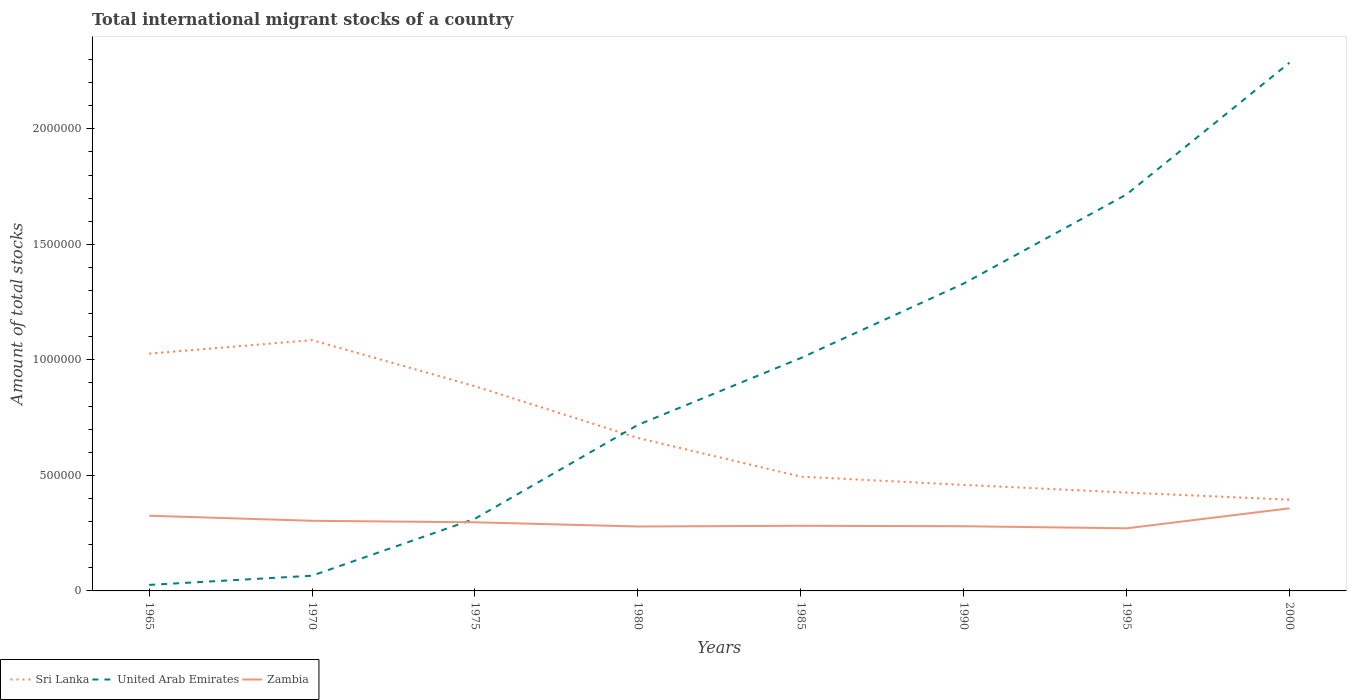How many different coloured lines are there?
Provide a succinct answer. 3. Does the line corresponding to Zambia intersect with the line corresponding to Sri Lanka?
Your response must be concise. No. Is the number of lines equal to the number of legend labels?
Provide a succinct answer. Yes. Across all years, what is the maximum amount of total stocks in in Zambia?
Give a very brief answer. 2.71e+05. In which year was the amount of total stocks in in Sri Lanka maximum?
Your answer should be compact. 2000. What is the total amount of total stocks in in Zambia in the graph?
Make the answer very short. 3.25e+04. What is the difference between the highest and the second highest amount of total stocks in in United Arab Emirates?
Offer a terse response. 2.26e+06. What is the difference between two consecutive major ticks on the Y-axis?
Keep it short and to the point. 5.00e+05. How many legend labels are there?
Your answer should be very brief. 3. What is the title of the graph?
Your answer should be very brief. Total international migrant stocks of a country. What is the label or title of the Y-axis?
Offer a terse response. Amount of total stocks. What is the Amount of total stocks in Sri Lanka in 1965?
Keep it short and to the point. 1.03e+06. What is the Amount of total stocks of United Arab Emirates in 1965?
Keep it short and to the point. 2.60e+04. What is the Amount of total stocks of Zambia in 1965?
Offer a terse response. 3.26e+05. What is the Amount of total stocks in Sri Lanka in 1970?
Your answer should be compact. 1.09e+06. What is the Amount of total stocks of United Arab Emirates in 1970?
Your answer should be compact. 6.58e+04. What is the Amount of total stocks of Zambia in 1970?
Your answer should be very brief. 3.03e+05. What is the Amount of total stocks in Sri Lanka in 1975?
Offer a very short reply. 8.86e+05. What is the Amount of total stocks of United Arab Emirates in 1975?
Ensure brevity in your answer.  3.12e+05. What is the Amount of total stocks of Zambia in 1975?
Provide a short and direct response. 2.97e+05. What is the Amount of total stocks in Sri Lanka in 1980?
Offer a terse response. 6.62e+05. What is the Amount of total stocks in United Arab Emirates in 1980?
Provide a short and direct response. 7.18e+05. What is the Amount of total stocks of Zambia in 1980?
Keep it short and to the point. 2.79e+05. What is the Amount of total stocks of Sri Lanka in 1985?
Your answer should be very brief. 4.95e+05. What is the Amount of total stocks of United Arab Emirates in 1985?
Your answer should be compact. 1.01e+06. What is the Amount of total stocks of Zambia in 1985?
Keep it short and to the point. 2.82e+05. What is the Amount of total stocks in Sri Lanka in 1990?
Keep it short and to the point. 4.59e+05. What is the Amount of total stocks of United Arab Emirates in 1990?
Give a very brief answer. 1.33e+06. What is the Amount of total stocks in Zambia in 1990?
Keep it short and to the point. 2.80e+05. What is the Amount of total stocks in Sri Lanka in 1995?
Offer a very short reply. 4.26e+05. What is the Amount of total stocks in United Arab Emirates in 1995?
Offer a terse response. 1.72e+06. What is the Amount of total stocks of Zambia in 1995?
Provide a short and direct response. 2.71e+05. What is the Amount of total stocks of Sri Lanka in 2000?
Keep it short and to the point. 3.95e+05. What is the Amount of total stocks of United Arab Emirates in 2000?
Your answer should be compact. 2.29e+06. What is the Amount of total stocks of Zambia in 2000?
Make the answer very short. 3.57e+05. Across all years, what is the maximum Amount of total stocks of Sri Lanka?
Your answer should be compact. 1.09e+06. Across all years, what is the maximum Amount of total stocks of United Arab Emirates?
Offer a terse response. 2.29e+06. Across all years, what is the maximum Amount of total stocks in Zambia?
Ensure brevity in your answer.  3.57e+05. Across all years, what is the minimum Amount of total stocks in Sri Lanka?
Your answer should be compact. 3.95e+05. Across all years, what is the minimum Amount of total stocks of United Arab Emirates?
Your answer should be very brief. 2.60e+04. Across all years, what is the minimum Amount of total stocks in Zambia?
Your answer should be very brief. 2.71e+05. What is the total Amount of total stocks of Sri Lanka in the graph?
Provide a short and direct response. 5.43e+06. What is the total Amount of total stocks of United Arab Emirates in the graph?
Provide a succinct answer. 7.46e+06. What is the total Amount of total stocks of Zambia in the graph?
Your response must be concise. 2.40e+06. What is the difference between the Amount of total stocks in Sri Lanka in 1965 and that in 1970?
Your answer should be very brief. -5.85e+04. What is the difference between the Amount of total stocks in United Arab Emirates in 1965 and that in 1970?
Provide a succinct answer. -3.98e+04. What is the difference between the Amount of total stocks of Zambia in 1965 and that in 1970?
Offer a very short reply. 2.20e+04. What is the difference between the Amount of total stocks of Sri Lanka in 1965 and that in 1975?
Offer a very short reply. 1.41e+05. What is the difference between the Amount of total stocks in United Arab Emirates in 1965 and that in 1975?
Keep it short and to the point. -2.86e+05. What is the difference between the Amount of total stocks in Zambia in 1965 and that in 1975?
Offer a very short reply. 2.84e+04. What is the difference between the Amount of total stocks in Sri Lanka in 1965 and that in 1980?
Provide a short and direct response. 3.65e+05. What is the difference between the Amount of total stocks in United Arab Emirates in 1965 and that in 1980?
Your answer should be very brief. -6.92e+05. What is the difference between the Amount of total stocks of Zambia in 1965 and that in 1980?
Offer a very short reply. 4.67e+04. What is the difference between the Amount of total stocks in Sri Lanka in 1965 and that in 1985?
Provide a succinct answer. 5.32e+05. What is the difference between the Amount of total stocks in United Arab Emirates in 1965 and that in 1985?
Provide a succinct answer. -9.82e+05. What is the difference between the Amount of total stocks in Zambia in 1965 and that in 1985?
Offer a very short reply. 4.36e+04. What is the difference between the Amount of total stocks in Sri Lanka in 1965 and that in 1990?
Provide a short and direct response. 5.68e+05. What is the difference between the Amount of total stocks in United Arab Emirates in 1965 and that in 1990?
Offer a very short reply. -1.30e+06. What is the difference between the Amount of total stocks of Zambia in 1965 and that in 1990?
Make the answer very short. 4.55e+04. What is the difference between the Amount of total stocks of Sri Lanka in 1965 and that in 1995?
Your answer should be compact. 6.01e+05. What is the difference between the Amount of total stocks of United Arab Emirates in 1965 and that in 1995?
Ensure brevity in your answer.  -1.69e+06. What is the difference between the Amount of total stocks in Zambia in 1965 and that in 1995?
Ensure brevity in your answer.  5.46e+04. What is the difference between the Amount of total stocks in Sri Lanka in 1965 and that in 2000?
Offer a very short reply. 6.32e+05. What is the difference between the Amount of total stocks of United Arab Emirates in 1965 and that in 2000?
Ensure brevity in your answer.  -2.26e+06. What is the difference between the Amount of total stocks of Zambia in 1965 and that in 2000?
Your answer should be compact. -3.20e+04. What is the difference between the Amount of total stocks in Sri Lanka in 1970 and that in 1975?
Make the answer very short. 2.00e+05. What is the difference between the Amount of total stocks in United Arab Emirates in 1970 and that in 1975?
Keep it short and to the point. -2.47e+05. What is the difference between the Amount of total stocks of Zambia in 1970 and that in 1975?
Make the answer very short. 6393. What is the difference between the Amount of total stocks in Sri Lanka in 1970 and that in 1980?
Make the answer very short. 4.24e+05. What is the difference between the Amount of total stocks in United Arab Emirates in 1970 and that in 1980?
Your response must be concise. -6.53e+05. What is the difference between the Amount of total stocks of Zambia in 1970 and that in 1980?
Offer a very short reply. 2.47e+04. What is the difference between the Amount of total stocks in Sri Lanka in 1970 and that in 1985?
Your response must be concise. 5.91e+05. What is the difference between the Amount of total stocks of United Arab Emirates in 1970 and that in 1985?
Keep it short and to the point. -9.42e+05. What is the difference between the Amount of total stocks in Zambia in 1970 and that in 1985?
Your response must be concise. 2.16e+04. What is the difference between the Amount of total stocks of Sri Lanka in 1970 and that in 1990?
Offer a terse response. 6.27e+05. What is the difference between the Amount of total stocks of United Arab Emirates in 1970 and that in 1990?
Make the answer very short. -1.26e+06. What is the difference between the Amount of total stocks in Zambia in 1970 and that in 1990?
Give a very brief answer. 2.35e+04. What is the difference between the Amount of total stocks in Sri Lanka in 1970 and that in 1995?
Your answer should be very brief. 6.60e+05. What is the difference between the Amount of total stocks of United Arab Emirates in 1970 and that in 1995?
Keep it short and to the point. -1.65e+06. What is the difference between the Amount of total stocks in Zambia in 1970 and that in 1995?
Ensure brevity in your answer.  3.25e+04. What is the difference between the Amount of total stocks in Sri Lanka in 1970 and that in 2000?
Ensure brevity in your answer.  6.90e+05. What is the difference between the Amount of total stocks in United Arab Emirates in 1970 and that in 2000?
Give a very brief answer. -2.22e+06. What is the difference between the Amount of total stocks of Zambia in 1970 and that in 2000?
Keep it short and to the point. -5.40e+04. What is the difference between the Amount of total stocks of Sri Lanka in 1975 and that in 1980?
Offer a terse response. 2.24e+05. What is the difference between the Amount of total stocks in United Arab Emirates in 1975 and that in 1980?
Provide a short and direct response. -4.06e+05. What is the difference between the Amount of total stocks in Zambia in 1975 and that in 1980?
Offer a very short reply. 1.83e+04. What is the difference between the Amount of total stocks of Sri Lanka in 1975 and that in 1985?
Provide a short and direct response. 3.91e+05. What is the difference between the Amount of total stocks of United Arab Emirates in 1975 and that in 1985?
Make the answer very short. -6.95e+05. What is the difference between the Amount of total stocks in Zambia in 1975 and that in 1985?
Keep it short and to the point. 1.52e+04. What is the difference between the Amount of total stocks of Sri Lanka in 1975 and that in 1990?
Offer a terse response. 4.27e+05. What is the difference between the Amount of total stocks in United Arab Emirates in 1975 and that in 1990?
Your answer should be very brief. -1.02e+06. What is the difference between the Amount of total stocks of Zambia in 1975 and that in 1990?
Keep it short and to the point. 1.71e+04. What is the difference between the Amount of total stocks of Sri Lanka in 1975 and that in 1995?
Your response must be concise. 4.60e+05. What is the difference between the Amount of total stocks of United Arab Emirates in 1975 and that in 1995?
Provide a short and direct response. -1.40e+06. What is the difference between the Amount of total stocks in Zambia in 1975 and that in 1995?
Offer a terse response. 2.61e+04. What is the difference between the Amount of total stocks of Sri Lanka in 1975 and that in 2000?
Ensure brevity in your answer.  4.91e+05. What is the difference between the Amount of total stocks of United Arab Emirates in 1975 and that in 2000?
Ensure brevity in your answer.  -1.97e+06. What is the difference between the Amount of total stocks of Zambia in 1975 and that in 2000?
Ensure brevity in your answer.  -6.04e+04. What is the difference between the Amount of total stocks of Sri Lanka in 1980 and that in 1985?
Ensure brevity in your answer.  1.67e+05. What is the difference between the Amount of total stocks of United Arab Emirates in 1980 and that in 1985?
Give a very brief answer. -2.89e+05. What is the difference between the Amount of total stocks of Zambia in 1980 and that in 1985?
Offer a terse response. -3108. What is the difference between the Amount of total stocks in Sri Lanka in 1980 and that in 1990?
Keep it short and to the point. 2.03e+05. What is the difference between the Amount of total stocks of United Arab Emirates in 1980 and that in 1990?
Keep it short and to the point. -6.12e+05. What is the difference between the Amount of total stocks of Zambia in 1980 and that in 1990?
Provide a succinct answer. -1171. What is the difference between the Amount of total stocks in Sri Lanka in 1980 and that in 1995?
Provide a succinct answer. 2.36e+05. What is the difference between the Amount of total stocks of United Arab Emirates in 1980 and that in 1995?
Your response must be concise. -9.98e+05. What is the difference between the Amount of total stocks in Zambia in 1980 and that in 1995?
Your answer should be very brief. 7841. What is the difference between the Amount of total stocks in Sri Lanka in 1980 and that in 2000?
Ensure brevity in your answer.  2.67e+05. What is the difference between the Amount of total stocks of United Arab Emirates in 1980 and that in 2000?
Make the answer very short. -1.57e+06. What is the difference between the Amount of total stocks of Zambia in 1980 and that in 2000?
Give a very brief answer. -7.87e+04. What is the difference between the Amount of total stocks in Sri Lanka in 1985 and that in 1990?
Provide a short and direct response. 3.57e+04. What is the difference between the Amount of total stocks in United Arab Emirates in 1985 and that in 1990?
Your answer should be very brief. -3.22e+05. What is the difference between the Amount of total stocks of Zambia in 1985 and that in 1990?
Make the answer very short. 1937. What is the difference between the Amount of total stocks in Sri Lanka in 1985 and that in 1995?
Make the answer very short. 6.89e+04. What is the difference between the Amount of total stocks of United Arab Emirates in 1985 and that in 1995?
Ensure brevity in your answer.  -7.08e+05. What is the difference between the Amount of total stocks in Zambia in 1985 and that in 1995?
Give a very brief answer. 1.09e+04. What is the difference between the Amount of total stocks in Sri Lanka in 1985 and that in 2000?
Your answer should be very brief. 9.97e+04. What is the difference between the Amount of total stocks in United Arab Emirates in 1985 and that in 2000?
Provide a succinct answer. -1.28e+06. What is the difference between the Amount of total stocks in Zambia in 1985 and that in 2000?
Keep it short and to the point. -7.56e+04. What is the difference between the Amount of total stocks in Sri Lanka in 1990 and that in 1995?
Provide a short and direct response. 3.32e+04. What is the difference between the Amount of total stocks in United Arab Emirates in 1990 and that in 1995?
Give a very brief answer. -3.86e+05. What is the difference between the Amount of total stocks in Zambia in 1990 and that in 1995?
Your answer should be compact. 9012. What is the difference between the Amount of total stocks in Sri Lanka in 1990 and that in 2000?
Your answer should be very brief. 6.39e+04. What is the difference between the Amount of total stocks in United Arab Emirates in 1990 and that in 2000?
Ensure brevity in your answer.  -9.56e+05. What is the difference between the Amount of total stocks in Zambia in 1990 and that in 2000?
Make the answer very short. -7.75e+04. What is the difference between the Amount of total stocks in Sri Lanka in 1995 and that in 2000?
Make the answer very short. 3.08e+04. What is the difference between the Amount of total stocks in United Arab Emirates in 1995 and that in 2000?
Your answer should be very brief. -5.70e+05. What is the difference between the Amount of total stocks of Zambia in 1995 and that in 2000?
Your answer should be very brief. -8.65e+04. What is the difference between the Amount of total stocks in Sri Lanka in 1965 and the Amount of total stocks in United Arab Emirates in 1970?
Provide a short and direct response. 9.61e+05. What is the difference between the Amount of total stocks of Sri Lanka in 1965 and the Amount of total stocks of Zambia in 1970?
Give a very brief answer. 7.23e+05. What is the difference between the Amount of total stocks in United Arab Emirates in 1965 and the Amount of total stocks in Zambia in 1970?
Provide a short and direct response. -2.77e+05. What is the difference between the Amount of total stocks in Sri Lanka in 1965 and the Amount of total stocks in United Arab Emirates in 1975?
Give a very brief answer. 7.14e+05. What is the difference between the Amount of total stocks of Sri Lanka in 1965 and the Amount of total stocks of Zambia in 1975?
Offer a terse response. 7.30e+05. What is the difference between the Amount of total stocks in United Arab Emirates in 1965 and the Amount of total stocks in Zambia in 1975?
Keep it short and to the point. -2.71e+05. What is the difference between the Amount of total stocks in Sri Lanka in 1965 and the Amount of total stocks in United Arab Emirates in 1980?
Your response must be concise. 3.08e+05. What is the difference between the Amount of total stocks of Sri Lanka in 1965 and the Amount of total stocks of Zambia in 1980?
Provide a succinct answer. 7.48e+05. What is the difference between the Amount of total stocks of United Arab Emirates in 1965 and the Amount of total stocks of Zambia in 1980?
Ensure brevity in your answer.  -2.53e+05. What is the difference between the Amount of total stocks of Sri Lanka in 1965 and the Amount of total stocks of United Arab Emirates in 1985?
Keep it short and to the point. 1.91e+04. What is the difference between the Amount of total stocks of Sri Lanka in 1965 and the Amount of total stocks of Zambia in 1985?
Your response must be concise. 7.45e+05. What is the difference between the Amount of total stocks in United Arab Emirates in 1965 and the Amount of total stocks in Zambia in 1985?
Ensure brevity in your answer.  -2.56e+05. What is the difference between the Amount of total stocks in Sri Lanka in 1965 and the Amount of total stocks in United Arab Emirates in 1990?
Your response must be concise. -3.03e+05. What is the difference between the Amount of total stocks in Sri Lanka in 1965 and the Amount of total stocks in Zambia in 1990?
Keep it short and to the point. 7.47e+05. What is the difference between the Amount of total stocks in United Arab Emirates in 1965 and the Amount of total stocks in Zambia in 1990?
Offer a terse response. -2.54e+05. What is the difference between the Amount of total stocks of Sri Lanka in 1965 and the Amount of total stocks of United Arab Emirates in 1995?
Provide a short and direct response. -6.89e+05. What is the difference between the Amount of total stocks of Sri Lanka in 1965 and the Amount of total stocks of Zambia in 1995?
Give a very brief answer. 7.56e+05. What is the difference between the Amount of total stocks in United Arab Emirates in 1965 and the Amount of total stocks in Zambia in 1995?
Offer a terse response. -2.45e+05. What is the difference between the Amount of total stocks in Sri Lanka in 1965 and the Amount of total stocks in United Arab Emirates in 2000?
Keep it short and to the point. -1.26e+06. What is the difference between the Amount of total stocks of Sri Lanka in 1965 and the Amount of total stocks of Zambia in 2000?
Make the answer very short. 6.69e+05. What is the difference between the Amount of total stocks of United Arab Emirates in 1965 and the Amount of total stocks of Zambia in 2000?
Provide a short and direct response. -3.31e+05. What is the difference between the Amount of total stocks in Sri Lanka in 1970 and the Amount of total stocks in United Arab Emirates in 1975?
Offer a very short reply. 7.73e+05. What is the difference between the Amount of total stocks of Sri Lanka in 1970 and the Amount of total stocks of Zambia in 1975?
Offer a very short reply. 7.88e+05. What is the difference between the Amount of total stocks in United Arab Emirates in 1970 and the Amount of total stocks in Zambia in 1975?
Offer a terse response. -2.31e+05. What is the difference between the Amount of total stocks in Sri Lanka in 1970 and the Amount of total stocks in United Arab Emirates in 1980?
Offer a terse response. 3.67e+05. What is the difference between the Amount of total stocks of Sri Lanka in 1970 and the Amount of total stocks of Zambia in 1980?
Offer a terse response. 8.07e+05. What is the difference between the Amount of total stocks in United Arab Emirates in 1970 and the Amount of total stocks in Zambia in 1980?
Your answer should be very brief. -2.13e+05. What is the difference between the Amount of total stocks of Sri Lanka in 1970 and the Amount of total stocks of United Arab Emirates in 1985?
Keep it short and to the point. 7.76e+04. What is the difference between the Amount of total stocks in Sri Lanka in 1970 and the Amount of total stocks in Zambia in 1985?
Your answer should be very brief. 8.04e+05. What is the difference between the Amount of total stocks in United Arab Emirates in 1970 and the Amount of total stocks in Zambia in 1985?
Your answer should be very brief. -2.16e+05. What is the difference between the Amount of total stocks in Sri Lanka in 1970 and the Amount of total stocks in United Arab Emirates in 1990?
Offer a very short reply. -2.45e+05. What is the difference between the Amount of total stocks in Sri Lanka in 1970 and the Amount of total stocks in Zambia in 1990?
Give a very brief answer. 8.05e+05. What is the difference between the Amount of total stocks in United Arab Emirates in 1970 and the Amount of total stocks in Zambia in 1990?
Keep it short and to the point. -2.14e+05. What is the difference between the Amount of total stocks of Sri Lanka in 1970 and the Amount of total stocks of United Arab Emirates in 1995?
Make the answer very short. -6.31e+05. What is the difference between the Amount of total stocks in Sri Lanka in 1970 and the Amount of total stocks in Zambia in 1995?
Provide a succinct answer. 8.14e+05. What is the difference between the Amount of total stocks in United Arab Emirates in 1970 and the Amount of total stocks in Zambia in 1995?
Offer a very short reply. -2.05e+05. What is the difference between the Amount of total stocks of Sri Lanka in 1970 and the Amount of total stocks of United Arab Emirates in 2000?
Ensure brevity in your answer.  -1.20e+06. What is the difference between the Amount of total stocks of Sri Lanka in 1970 and the Amount of total stocks of Zambia in 2000?
Provide a succinct answer. 7.28e+05. What is the difference between the Amount of total stocks in United Arab Emirates in 1970 and the Amount of total stocks in Zambia in 2000?
Your answer should be very brief. -2.92e+05. What is the difference between the Amount of total stocks in Sri Lanka in 1975 and the Amount of total stocks in United Arab Emirates in 1980?
Make the answer very short. 1.67e+05. What is the difference between the Amount of total stocks in Sri Lanka in 1975 and the Amount of total stocks in Zambia in 1980?
Offer a terse response. 6.07e+05. What is the difference between the Amount of total stocks in United Arab Emirates in 1975 and the Amount of total stocks in Zambia in 1980?
Your response must be concise. 3.36e+04. What is the difference between the Amount of total stocks in Sri Lanka in 1975 and the Amount of total stocks in United Arab Emirates in 1985?
Provide a succinct answer. -1.22e+05. What is the difference between the Amount of total stocks in Sri Lanka in 1975 and the Amount of total stocks in Zambia in 1985?
Ensure brevity in your answer.  6.04e+05. What is the difference between the Amount of total stocks of United Arab Emirates in 1975 and the Amount of total stocks of Zambia in 1985?
Give a very brief answer. 3.05e+04. What is the difference between the Amount of total stocks in Sri Lanka in 1975 and the Amount of total stocks in United Arab Emirates in 1990?
Your answer should be very brief. -4.44e+05. What is the difference between the Amount of total stocks in Sri Lanka in 1975 and the Amount of total stocks in Zambia in 1990?
Ensure brevity in your answer.  6.06e+05. What is the difference between the Amount of total stocks of United Arab Emirates in 1975 and the Amount of total stocks of Zambia in 1990?
Give a very brief answer. 3.24e+04. What is the difference between the Amount of total stocks of Sri Lanka in 1975 and the Amount of total stocks of United Arab Emirates in 1995?
Your answer should be compact. -8.30e+05. What is the difference between the Amount of total stocks of Sri Lanka in 1975 and the Amount of total stocks of Zambia in 1995?
Ensure brevity in your answer.  6.15e+05. What is the difference between the Amount of total stocks in United Arab Emirates in 1975 and the Amount of total stocks in Zambia in 1995?
Offer a very short reply. 4.14e+04. What is the difference between the Amount of total stocks of Sri Lanka in 1975 and the Amount of total stocks of United Arab Emirates in 2000?
Offer a terse response. -1.40e+06. What is the difference between the Amount of total stocks of Sri Lanka in 1975 and the Amount of total stocks of Zambia in 2000?
Your response must be concise. 5.28e+05. What is the difference between the Amount of total stocks of United Arab Emirates in 1975 and the Amount of total stocks of Zambia in 2000?
Provide a short and direct response. -4.51e+04. What is the difference between the Amount of total stocks in Sri Lanka in 1980 and the Amount of total stocks in United Arab Emirates in 1985?
Ensure brevity in your answer.  -3.46e+05. What is the difference between the Amount of total stocks in Sri Lanka in 1980 and the Amount of total stocks in Zambia in 1985?
Ensure brevity in your answer.  3.80e+05. What is the difference between the Amount of total stocks in United Arab Emirates in 1980 and the Amount of total stocks in Zambia in 1985?
Offer a terse response. 4.37e+05. What is the difference between the Amount of total stocks of Sri Lanka in 1980 and the Amount of total stocks of United Arab Emirates in 1990?
Your response must be concise. -6.68e+05. What is the difference between the Amount of total stocks of Sri Lanka in 1980 and the Amount of total stocks of Zambia in 1990?
Offer a very short reply. 3.82e+05. What is the difference between the Amount of total stocks of United Arab Emirates in 1980 and the Amount of total stocks of Zambia in 1990?
Offer a very short reply. 4.39e+05. What is the difference between the Amount of total stocks in Sri Lanka in 1980 and the Amount of total stocks in United Arab Emirates in 1995?
Provide a succinct answer. -1.05e+06. What is the difference between the Amount of total stocks in Sri Lanka in 1980 and the Amount of total stocks in Zambia in 1995?
Ensure brevity in your answer.  3.91e+05. What is the difference between the Amount of total stocks in United Arab Emirates in 1980 and the Amount of total stocks in Zambia in 1995?
Provide a succinct answer. 4.48e+05. What is the difference between the Amount of total stocks in Sri Lanka in 1980 and the Amount of total stocks in United Arab Emirates in 2000?
Offer a very short reply. -1.62e+06. What is the difference between the Amount of total stocks in Sri Lanka in 1980 and the Amount of total stocks in Zambia in 2000?
Provide a short and direct response. 3.04e+05. What is the difference between the Amount of total stocks of United Arab Emirates in 1980 and the Amount of total stocks of Zambia in 2000?
Offer a terse response. 3.61e+05. What is the difference between the Amount of total stocks of Sri Lanka in 1985 and the Amount of total stocks of United Arab Emirates in 1990?
Your answer should be very brief. -8.36e+05. What is the difference between the Amount of total stocks in Sri Lanka in 1985 and the Amount of total stocks in Zambia in 1990?
Offer a very short reply. 2.15e+05. What is the difference between the Amount of total stocks of United Arab Emirates in 1985 and the Amount of total stocks of Zambia in 1990?
Keep it short and to the point. 7.28e+05. What is the difference between the Amount of total stocks in Sri Lanka in 1985 and the Amount of total stocks in United Arab Emirates in 1995?
Provide a succinct answer. -1.22e+06. What is the difference between the Amount of total stocks of Sri Lanka in 1985 and the Amount of total stocks of Zambia in 1995?
Your response must be concise. 2.24e+05. What is the difference between the Amount of total stocks of United Arab Emirates in 1985 and the Amount of total stocks of Zambia in 1995?
Provide a short and direct response. 7.37e+05. What is the difference between the Amount of total stocks of Sri Lanka in 1985 and the Amount of total stocks of United Arab Emirates in 2000?
Keep it short and to the point. -1.79e+06. What is the difference between the Amount of total stocks in Sri Lanka in 1985 and the Amount of total stocks in Zambia in 2000?
Make the answer very short. 1.37e+05. What is the difference between the Amount of total stocks in United Arab Emirates in 1985 and the Amount of total stocks in Zambia in 2000?
Keep it short and to the point. 6.50e+05. What is the difference between the Amount of total stocks of Sri Lanka in 1990 and the Amount of total stocks of United Arab Emirates in 1995?
Your answer should be very brief. -1.26e+06. What is the difference between the Amount of total stocks of Sri Lanka in 1990 and the Amount of total stocks of Zambia in 1995?
Your answer should be compact. 1.88e+05. What is the difference between the Amount of total stocks in United Arab Emirates in 1990 and the Amount of total stocks in Zambia in 1995?
Your response must be concise. 1.06e+06. What is the difference between the Amount of total stocks in Sri Lanka in 1990 and the Amount of total stocks in United Arab Emirates in 2000?
Ensure brevity in your answer.  -1.83e+06. What is the difference between the Amount of total stocks of Sri Lanka in 1990 and the Amount of total stocks of Zambia in 2000?
Your response must be concise. 1.01e+05. What is the difference between the Amount of total stocks in United Arab Emirates in 1990 and the Amount of total stocks in Zambia in 2000?
Your answer should be very brief. 9.73e+05. What is the difference between the Amount of total stocks in Sri Lanka in 1995 and the Amount of total stocks in United Arab Emirates in 2000?
Your answer should be very brief. -1.86e+06. What is the difference between the Amount of total stocks of Sri Lanka in 1995 and the Amount of total stocks of Zambia in 2000?
Provide a succinct answer. 6.82e+04. What is the difference between the Amount of total stocks of United Arab Emirates in 1995 and the Amount of total stocks of Zambia in 2000?
Give a very brief answer. 1.36e+06. What is the average Amount of total stocks in Sri Lanka per year?
Your response must be concise. 6.79e+05. What is the average Amount of total stocks of United Arab Emirates per year?
Make the answer very short. 9.33e+05. What is the average Amount of total stocks of Zambia per year?
Offer a terse response. 2.99e+05. In the year 1965, what is the difference between the Amount of total stocks in Sri Lanka and Amount of total stocks in United Arab Emirates?
Offer a terse response. 1.00e+06. In the year 1965, what is the difference between the Amount of total stocks of Sri Lanka and Amount of total stocks of Zambia?
Provide a short and direct response. 7.01e+05. In the year 1965, what is the difference between the Amount of total stocks of United Arab Emirates and Amount of total stocks of Zambia?
Your answer should be very brief. -3.00e+05. In the year 1970, what is the difference between the Amount of total stocks in Sri Lanka and Amount of total stocks in United Arab Emirates?
Make the answer very short. 1.02e+06. In the year 1970, what is the difference between the Amount of total stocks in Sri Lanka and Amount of total stocks in Zambia?
Provide a short and direct response. 7.82e+05. In the year 1970, what is the difference between the Amount of total stocks of United Arab Emirates and Amount of total stocks of Zambia?
Your answer should be compact. -2.38e+05. In the year 1975, what is the difference between the Amount of total stocks in Sri Lanka and Amount of total stocks in United Arab Emirates?
Give a very brief answer. 5.73e+05. In the year 1975, what is the difference between the Amount of total stocks of Sri Lanka and Amount of total stocks of Zambia?
Your answer should be compact. 5.89e+05. In the year 1975, what is the difference between the Amount of total stocks of United Arab Emirates and Amount of total stocks of Zambia?
Provide a succinct answer. 1.53e+04. In the year 1980, what is the difference between the Amount of total stocks in Sri Lanka and Amount of total stocks in United Arab Emirates?
Make the answer very short. -5.66e+04. In the year 1980, what is the difference between the Amount of total stocks in Sri Lanka and Amount of total stocks in Zambia?
Keep it short and to the point. 3.83e+05. In the year 1980, what is the difference between the Amount of total stocks of United Arab Emirates and Amount of total stocks of Zambia?
Ensure brevity in your answer.  4.40e+05. In the year 1985, what is the difference between the Amount of total stocks of Sri Lanka and Amount of total stocks of United Arab Emirates?
Offer a very short reply. -5.13e+05. In the year 1985, what is the difference between the Amount of total stocks in Sri Lanka and Amount of total stocks in Zambia?
Ensure brevity in your answer.  2.13e+05. In the year 1985, what is the difference between the Amount of total stocks in United Arab Emirates and Amount of total stocks in Zambia?
Offer a very short reply. 7.26e+05. In the year 1990, what is the difference between the Amount of total stocks of Sri Lanka and Amount of total stocks of United Arab Emirates?
Your answer should be very brief. -8.71e+05. In the year 1990, what is the difference between the Amount of total stocks of Sri Lanka and Amount of total stocks of Zambia?
Make the answer very short. 1.79e+05. In the year 1990, what is the difference between the Amount of total stocks in United Arab Emirates and Amount of total stocks in Zambia?
Offer a terse response. 1.05e+06. In the year 1995, what is the difference between the Amount of total stocks in Sri Lanka and Amount of total stocks in United Arab Emirates?
Provide a short and direct response. -1.29e+06. In the year 1995, what is the difference between the Amount of total stocks in Sri Lanka and Amount of total stocks in Zambia?
Your answer should be compact. 1.55e+05. In the year 1995, what is the difference between the Amount of total stocks in United Arab Emirates and Amount of total stocks in Zambia?
Provide a succinct answer. 1.45e+06. In the year 2000, what is the difference between the Amount of total stocks of Sri Lanka and Amount of total stocks of United Arab Emirates?
Provide a short and direct response. -1.89e+06. In the year 2000, what is the difference between the Amount of total stocks of Sri Lanka and Amount of total stocks of Zambia?
Your response must be concise. 3.75e+04. In the year 2000, what is the difference between the Amount of total stocks in United Arab Emirates and Amount of total stocks in Zambia?
Your answer should be very brief. 1.93e+06. What is the ratio of the Amount of total stocks of Sri Lanka in 1965 to that in 1970?
Give a very brief answer. 0.95. What is the ratio of the Amount of total stocks in United Arab Emirates in 1965 to that in 1970?
Make the answer very short. 0.39. What is the ratio of the Amount of total stocks of Zambia in 1965 to that in 1970?
Your answer should be very brief. 1.07. What is the ratio of the Amount of total stocks of Sri Lanka in 1965 to that in 1975?
Your answer should be compact. 1.16. What is the ratio of the Amount of total stocks of United Arab Emirates in 1965 to that in 1975?
Offer a terse response. 0.08. What is the ratio of the Amount of total stocks of Zambia in 1965 to that in 1975?
Offer a very short reply. 1.1. What is the ratio of the Amount of total stocks in Sri Lanka in 1965 to that in 1980?
Provide a short and direct response. 1.55. What is the ratio of the Amount of total stocks of United Arab Emirates in 1965 to that in 1980?
Provide a short and direct response. 0.04. What is the ratio of the Amount of total stocks of Zambia in 1965 to that in 1980?
Provide a short and direct response. 1.17. What is the ratio of the Amount of total stocks in Sri Lanka in 1965 to that in 1985?
Offer a very short reply. 2.08. What is the ratio of the Amount of total stocks in United Arab Emirates in 1965 to that in 1985?
Your answer should be very brief. 0.03. What is the ratio of the Amount of total stocks of Zambia in 1965 to that in 1985?
Offer a terse response. 1.15. What is the ratio of the Amount of total stocks of Sri Lanka in 1965 to that in 1990?
Keep it short and to the point. 2.24. What is the ratio of the Amount of total stocks of United Arab Emirates in 1965 to that in 1990?
Give a very brief answer. 0.02. What is the ratio of the Amount of total stocks in Zambia in 1965 to that in 1990?
Offer a terse response. 1.16. What is the ratio of the Amount of total stocks in Sri Lanka in 1965 to that in 1995?
Ensure brevity in your answer.  2.41. What is the ratio of the Amount of total stocks of United Arab Emirates in 1965 to that in 1995?
Ensure brevity in your answer.  0.02. What is the ratio of the Amount of total stocks in Zambia in 1965 to that in 1995?
Give a very brief answer. 1.2. What is the ratio of the Amount of total stocks in Sri Lanka in 1965 to that in 2000?
Your answer should be compact. 2.6. What is the ratio of the Amount of total stocks in United Arab Emirates in 1965 to that in 2000?
Offer a terse response. 0.01. What is the ratio of the Amount of total stocks in Zambia in 1965 to that in 2000?
Your answer should be very brief. 0.91. What is the ratio of the Amount of total stocks of Sri Lanka in 1970 to that in 1975?
Your response must be concise. 1.23. What is the ratio of the Amount of total stocks in United Arab Emirates in 1970 to that in 1975?
Keep it short and to the point. 0.21. What is the ratio of the Amount of total stocks in Zambia in 1970 to that in 1975?
Make the answer very short. 1.02. What is the ratio of the Amount of total stocks of Sri Lanka in 1970 to that in 1980?
Keep it short and to the point. 1.64. What is the ratio of the Amount of total stocks of United Arab Emirates in 1970 to that in 1980?
Your answer should be very brief. 0.09. What is the ratio of the Amount of total stocks of Zambia in 1970 to that in 1980?
Make the answer very short. 1.09. What is the ratio of the Amount of total stocks of Sri Lanka in 1970 to that in 1985?
Your response must be concise. 2.19. What is the ratio of the Amount of total stocks of United Arab Emirates in 1970 to that in 1985?
Give a very brief answer. 0.07. What is the ratio of the Amount of total stocks of Zambia in 1970 to that in 1985?
Make the answer very short. 1.08. What is the ratio of the Amount of total stocks in Sri Lanka in 1970 to that in 1990?
Offer a very short reply. 2.37. What is the ratio of the Amount of total stocks of United Arab Emirates in 1970 to that in 1990?
Ensure brevity in your answer.  0.05. What is the ratio of the Amount of total stocks in Zambia in 1970 to that in 1990?
Your answer should be compact. 1.08. What is the ratio of the Amount of total stocks in Sri Lanka in 1970 to that in 1995?
Your response must be concise. 2.55. What is the ratio of the Amount of total stocks in United Arab Emirates in 1970 to that in 1995?
Ensure brevity in your answer.  0.04. What is the ratio of the Amount of total stocks in Zambia in 1970 to that in 1995?
Provide a succinct answer. 1.12. What is the ratio of the Amount of total stocks of Sri Lanka in 1970 to that in 2000?
Give a very brief answer. 2.75. What is the ratio of the Amount of total stocks of United Arab Emirates in 1970 to that in 2000?
Your response must be concise. 0.03. What is the ratio of the Amount of total stocks in Zambia in 1970 to that in 2000?
Your answer should be compact. 0.85. What is the ratio of the Amount of total stocks in Sri Lanka in 1975 to that in 1980?
Provide a succinct answer. 1.34. What is the ratio of the Amount of total stocks in United Arab Emirates in 1975 to that in 1980?
Offer a very short reply. 0.43. What is the ratio of the Amount of total stocks in Zambia in 1975 to that in 1980?
Offer a terse response. 1.07. What is the ratio of the Amount of total stocks in Sri Lanka in 1975 to that in 1985?
Provide a succinct answer. 1.79. What is the ratio of the Amount of total stocks of United Arab Emirates in 1975 to that in 1985?
Your answer should be compact. 0.31. What is the ratio of the Amount of total stocks in Zambia in 1975 to that in 1985?
Provide a short and direct response. 1.05. What is the ratio of the Amount of total stocks in Sri Lanka in 1975 to that in 1990?
Offer a very short reply. 1.93. What is the ratio of the Amount of total stocks of United Arab Emirates in 1975 to that in 1990?
Give a very brief answer. 0.23. What is the ratio of the Amount of total stocks of Zambia in 1975 to that in 1990?
Keep it short and to the point. 1.06. What is the ratio of the Amount of total stocks in Sri Lanka in 1975 to that in 1995?
Provide a succinct answer. 2.08. What is the ratio of the Amount of total stocks of United Arab Emirates in 1975 to that in 1995?
Provide a succinct answer. 0.18. What is the ratio of the Amount of total stocks of Zambia in 1975 to that in 1995?
Provide a short and direct response. 1.1. What is the ratio of the Amount of total stocks of Sri Lanka in 1975 to that in 2000?
Give a very brief answer. 2.24. What is the ratio of the Amount of total stocks of United Arab Emirates in 1975 to that in 2000?
Provide a short and direct response. 0.14. What is the ratio of the Amount of total stocks in Zambia in 1975 to that in 2000?
Ensure brevity in your answer.  0.83. What is the ratio of the Amount of total stocks in Sri Lanka in 1980 to that in 1985?
Your response must be concise. 1.34. What is the ratio of the Amount of total stocks in United Arab Emirates in 1980 to that in 1985?
Offer a very short reply. 0.71. What is the ratio of the Amount of total stocks of Zambia in 1980 to that in 1985?
Keep it short and to the point. 0.99. What is the ratio of the Amount of total stocks of Sri Lanka in 1980 to that in 1990?
Your answer should be very brief. 1.44. What is the ratio of the Amount of total stocks of United Arab Emirates in 1980 to that in 1990?
Ensure brevity in your answer.  0.54. What is the ratio of the Amount of total stocks in Zambia in 1980 to that in 1990?
Provide a succinct answer. 1. What is the ratio of the Amount of total stocks in Sri Lanka in 1980 to that in 1995?
Give a very brief answer. 1.55. What is the ratio of the Amount of total stocks in United Arab Emirates in 1980 to that in 1995?
Make the answer very short. 0.42. What is the ratio of the Amount of total stocks in Zambia in 1980 to that in 1995?
Keep it short and to the point. 1.03. What is the ratio of the Amount of total stocks in Sri Lanka in 1980 to that in 2000?
Offer a terse response. 1.68. What is the ratio of the Amount of total stocks in United Arab Emirates in 1980 to that in 2000?
Offer a terse response. 0.31. What is the ratio of the Amount of total stocks of Zambia in 1980 to that in 2000?
Keep it short and to the point. 0.78. What is the ratio of the Amount of total stocks of Sri Lanka in 1985 to that in 1990?
Offer a terse response. 1.08. What is the ratio of the Amount of total stocks of United Arab Emirates in 1985 to that in 1990?
Provide a succinct answer. 0.76. What is the ratio of the Amount of total stocks in Zambia in 1985 to that in 1990?
Your answer should be compact. 1.01. What is the ratio of the Amount of total stocks of Sri Lanka in 1985 to that in 1995?
Make the answer very short. 1.16. What is the ratio of the Amount of total stocks of United Arab Emirates in 1985 to that in 1995?
Your answer should be very brief. 0.59. What is the ratio of the Amount of total stocks of Zambia in 1985 to that in 1995?
Offer a terse response. 1.04. What is the ratio of the Amount of total stocks of Sri Lanka in 1985 to that in 2000?
Make the answer very short. 1.25. What is the ratio of the Amount of total stocks in United Arab Emirates in 1985 to that in 2000?
Provide a short and direct response. 0.44. What is the ratio of the Amount of total stocks of Zambia in 1985 to that in 2000?
Provide a short and direct response. 0.79. What is the ratio of the Amount of total stocks of Sri Lanka in 1990 to that in 1995?
Your answer should be compact. 1.08. What is the ratio of the Amount of total stocks of United Arab Emirates in 1990 to that in 1995?
Give a very brief answer. 0.78. What is the ratio of the Amount of total stocks in Sri Lanka in 1990 to that in 2000?
Your answer should be compact. 1.16. What is the ratio of the Amount of total stocks in United Arab Emirates in 1990 to that in 2000?
Keep it short and to the point. 0.58. What is the ratio of the Amount of total stocks in Zambia in 1990 to that in 2000?
Your answer should be very brief. 0.78. What is the ratio of the Amount of total stocks of Sri Lanka in 1995 to that in 2000?
Provide a succinct answer. 1.08. What is the ratio of the Amount of total stocks of United Arab Emirates in 1995 to that in 2000?
Your answer should be compact. 0.75. What is the ratio of the Amount of total stocks in Zambia in 1995 to that in 2000?
Your answer should be compact. 0.76. What is the difference between the highest and the second highest Amount of total stocks of Sri Lanka?
Your answer should be compact. 5.85e+04. What is the difference between the highest and the second highest Amount of total stocks of United Arab Emirates?
Offer a terse response. 5.70e+05. What is the difference between the highest and the second highest Amount of total stocks of Zambia?
Give a very brief answer. 3.20e+04. What is the difference between the highest and the lowest Amount of total stocks in Sri Lanka?
Provide a succinct answer. 6.90e+05. What is the difference between the highest and the lowest Amount of total stocks in United Arab Emirates?
Your answer should be very brief. 2.26e+06. What is the difference between the highest and the lowest Amount of total stocks in Zambia?
Your answer should be very brief. 8.65e+04. 